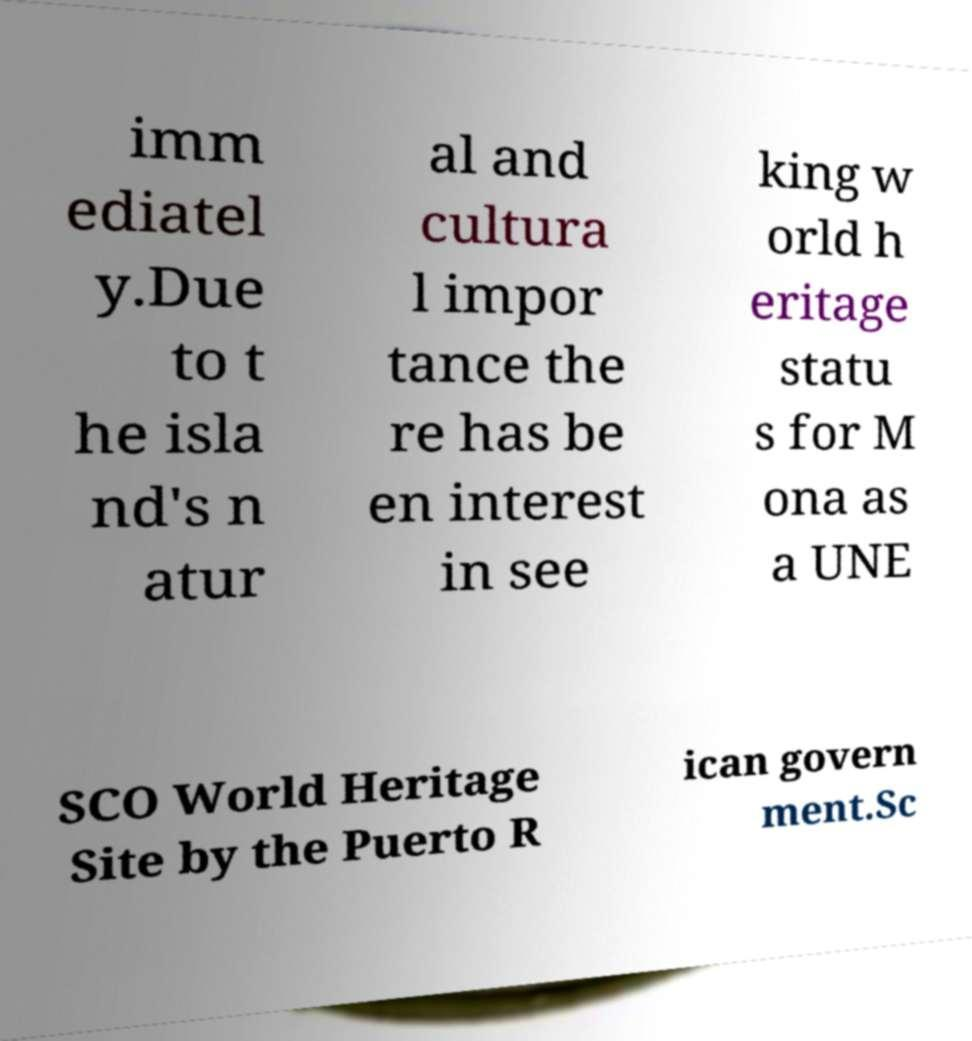Could you extract and type out the text from this image? imm ediatel y.Due to t he isla nd's n atur al and cultura l impor tance the re has be en interest in see king w orld h eritage statu s for M ona as a UNE SCO World Heritage Site by the Puerto R ican govern ment.Sc 